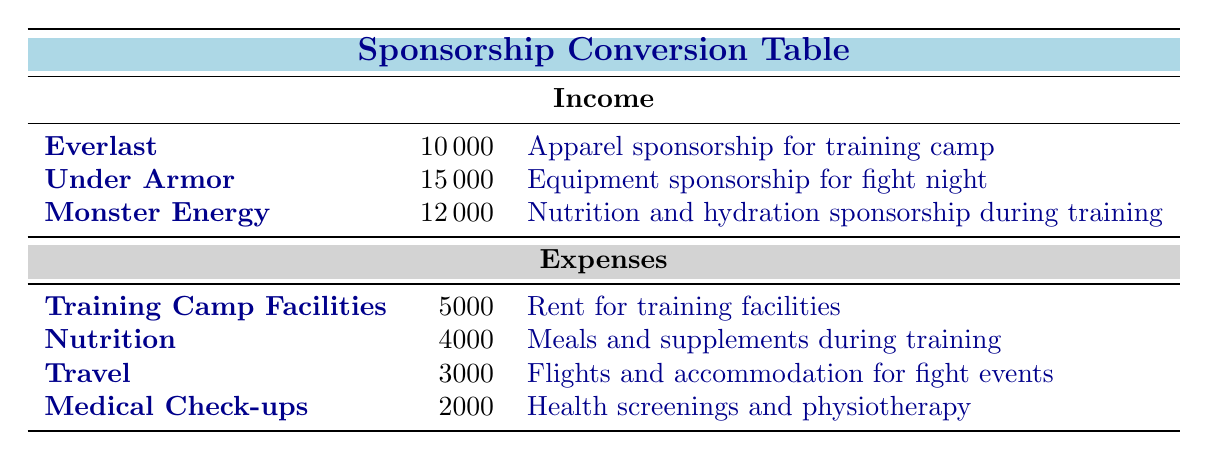What is the total sponsorship income? To find the total sponsorship income, we sum up the amounts for each sponsor: 10000 (Everlast) + 15000 (Under Armor) + 12000 (Monster Energy) = 37000.
Answer: 37000 What is the amount spent on Nutrition? The table lists Nutrition as an expense with an amount of 4000.
Answer: 4000 Is the expense for Travel greater than Medical Check-ups? The amount for Travel is 3000 and for Medical Check-ups is 2000. Since 3000 is greater than 2000, the statement is true.
Answer: Yes What is the average sponsorship income per sponsor? There are 3 sponsors, and their total income is 37000. To find the average, divide the total income by the number of sponsors: 37000 / 3 = 12333.33.
Answer: 12333.33 What is the total expense for all categories? To calculate the total expenses, we sum up all the amounts: 5000 (Training Camp Facilities) + 4000 (Nutrition) + 3000 (Travel) + 2000 (Medical Check-ups) = 14000.
Answer: 14000 Is there a sponsorship specifically for Nutrition and hydration? Yes, Monster Energy provides a sponsorship specifically for Nutrition and hydration, as described in the table.
Answer: Yes What is the difference between the highest and lowest sponsorship income? The highest sponsorship income is 15000 (Under Armor) and the lowest is 10000 (Everlast). The difference is 15000 - 10000 = 5000.
Answer: 5000 What percentage of the total income is attributed to Monster Energy? Monster Energy's sponsorship amount is 12000. To calculate the percentage of total income (37000), use the formula: (12000 / 37000) * 100 = approximately 32.43%.
Answer: 32.43% What is the total income from sponsors related to equipment? The table shows that Under Armor provides equipment sponsorship, amounting to 15000. There are no other sponsors listed for equipment, so the total is simply 15000.
Answer: 15000 